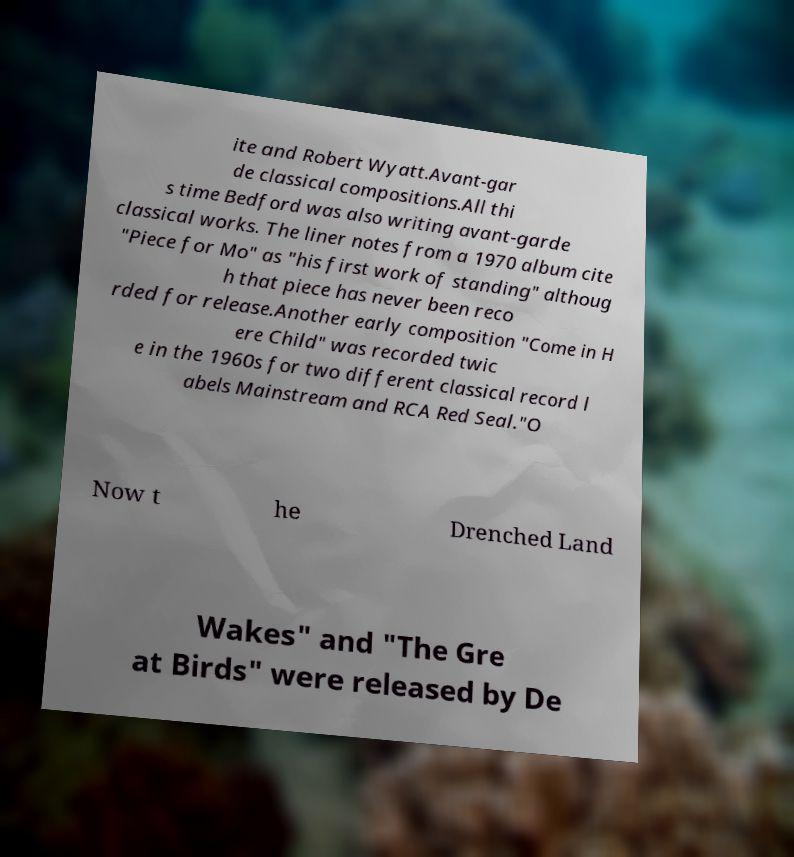Please identify and transcribe the text found in this image. ite and Robert Wyatt.Avant-gar de classical compositions.All thi s time Bedford was also writing avant-garde classical works. The liner notes from a 1970 album cite "Piece for Mo" as "his first work of standing" althoug h that piece has never been reco rded for release.Another early composition "Come in H ere Child" was recorded twic e in the 1960s for two different classical record l abels Mainstream and RCA Red Seal."O Now t he Drenched Land Wakes" and "The Gre at Birds" were released by De 